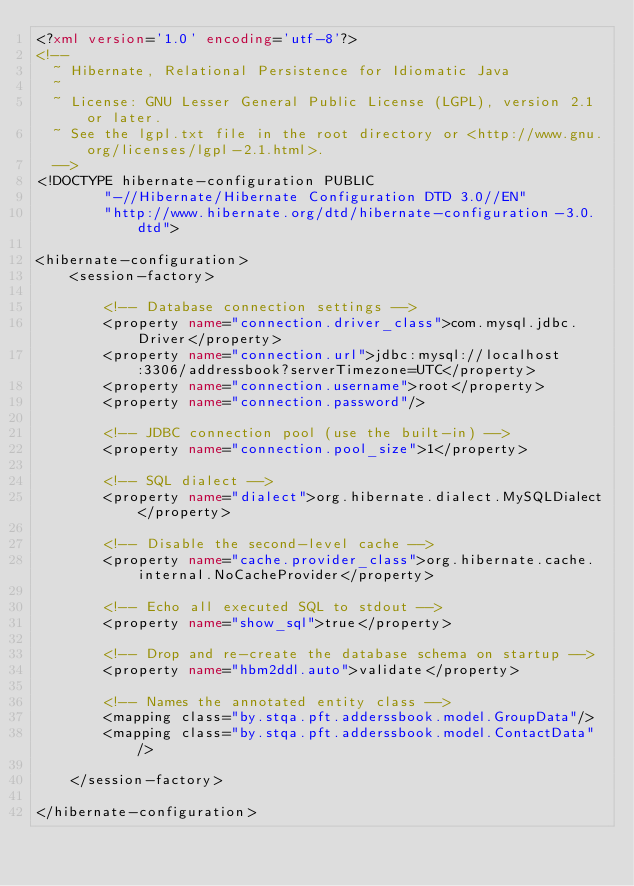Convert code to text. <code><loc_0><loc_0><loc_500><loc_500><_XML_><?xml version='1.0' encoding='utf-8'?>
<!--
  ~ Hibernate, Relational Persistence for Idiomatic Java
  ~
  ~ License: GNU Lesser General Public License (LGPL), version 2.1 or later.
  ~ See the lgpl.txt file in the root directory or <http://www.gnu.org/licenses/lgpl-2.1.html>.
  -->
<!DOCTYPE hibernate-configuration PUBLIC
        "-//Hibernate/Hibernate Configuration DTD 3.0//EN"
        "http://www.hibernate.org/dtd/hibernate-configuration-3.0.dtd">

<hibernate-configuration>
    <session-factory>

        <!-- Database connection settings -->
        <property name="connection.driver_class">com.mysql.jdbc.Driver</property>
        <property name="connection.url">jdbc:mysql://localhost:3306/addressbook?serverTimezone=UTC</property>
        <property name="connection.username">root</property>
        <property name="connection.password"/>

        <!-- JDBC connection pool (use the built-in) -->
        <property name="connection.pool_size">1</property>

        <!-- SQL dialect -->
        <property name="dialect">org.hibernate.dialect.MySQLDialect</property>

        <!-- Disable the second-level cache -->
        <property name="cache.provider_class">org.hibernate.cache.internal.NoCacheProvider</property>

        <!-- Echo all executed SQL to stdout -->
        <property name="show_sql">true</property>

        <!-- Drop and re-create the database schema on startup -->
        <property name="hbm2ddl.auto">validate</property>

        <!-- Names the annotated entity class -->
        <mapping class="by.stqa.pft.adderssbook.model.GroupData"/>
        <mapping class="by.stqa.pft.adderssbook.model.ContactData"/>

    </session-factory>

</hibernate-configuration></code> 